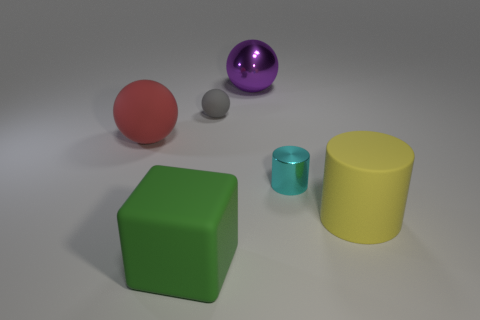Is the shape of the big yellow thing the same as the tiny object to the right of the purple object?
Your answer should be very brief. Yes. What number of green things are the same size as the metallic cylinder?
Give a very brief answer. 0. There is a small object left of the big ball on the right side of the small gray rubber ball; what number of big cylinders are on the left side of it?
Offer a very short reply. 0. Are there the same number of big green cubes to the left of the red matte object and large things that are in front of the big green rubber object?
Offer a terse response. Yes. How many other green rubber objects have the same shape as the big green object?
Offer a very short reply. 0. Are there any small cyan cylinders that have the same material as the large red sphere?
Provide a succinct answer. No. What number of matte cylinders are there?
Offer a terse response. 1. How many cylinders are big yellow rubber objects or large metal things?
Provide a short and direct response. 1. What is the color of the rubber ball that is the same size as the yellow matte cylinder?
Make the answer very short. Red. How many matte objects are both to the right of the metal ball and in front of the big yellow cylinder?
Ensure brevity in your answer.  0. 